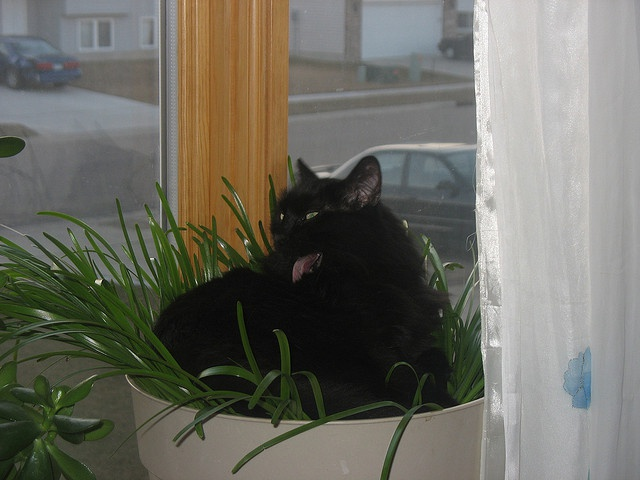Describe the objects in this image and their specific colors. I can see potted plant in gray, black, and darkgreen tones, cat in gray, black, and darkgreen tones, car in gray, black, darkgray, and darkgreen tones, car in gray tones, and car in gray tones in this image. 